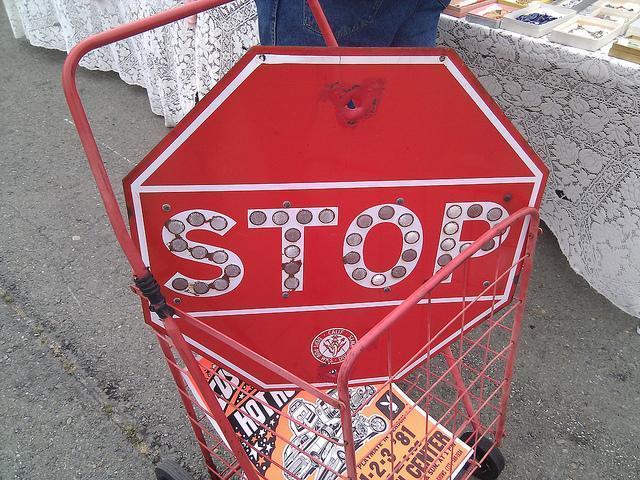How many birds are pictured?
Give a very brief answer. 0. 